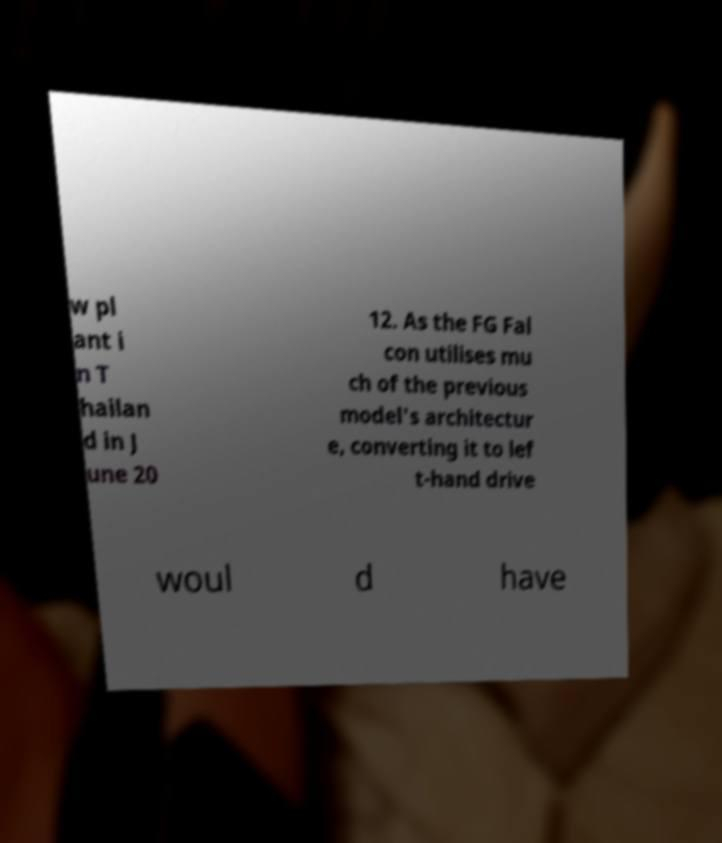For documentation purposes, I need the text within this image transcribed. Could you provide that? w pl ant i n T hailan d in J une 20 12. As the FG Fal con utilises mu ch of the previous model's architectur e, converting it to lef t-hand drive woul d have 